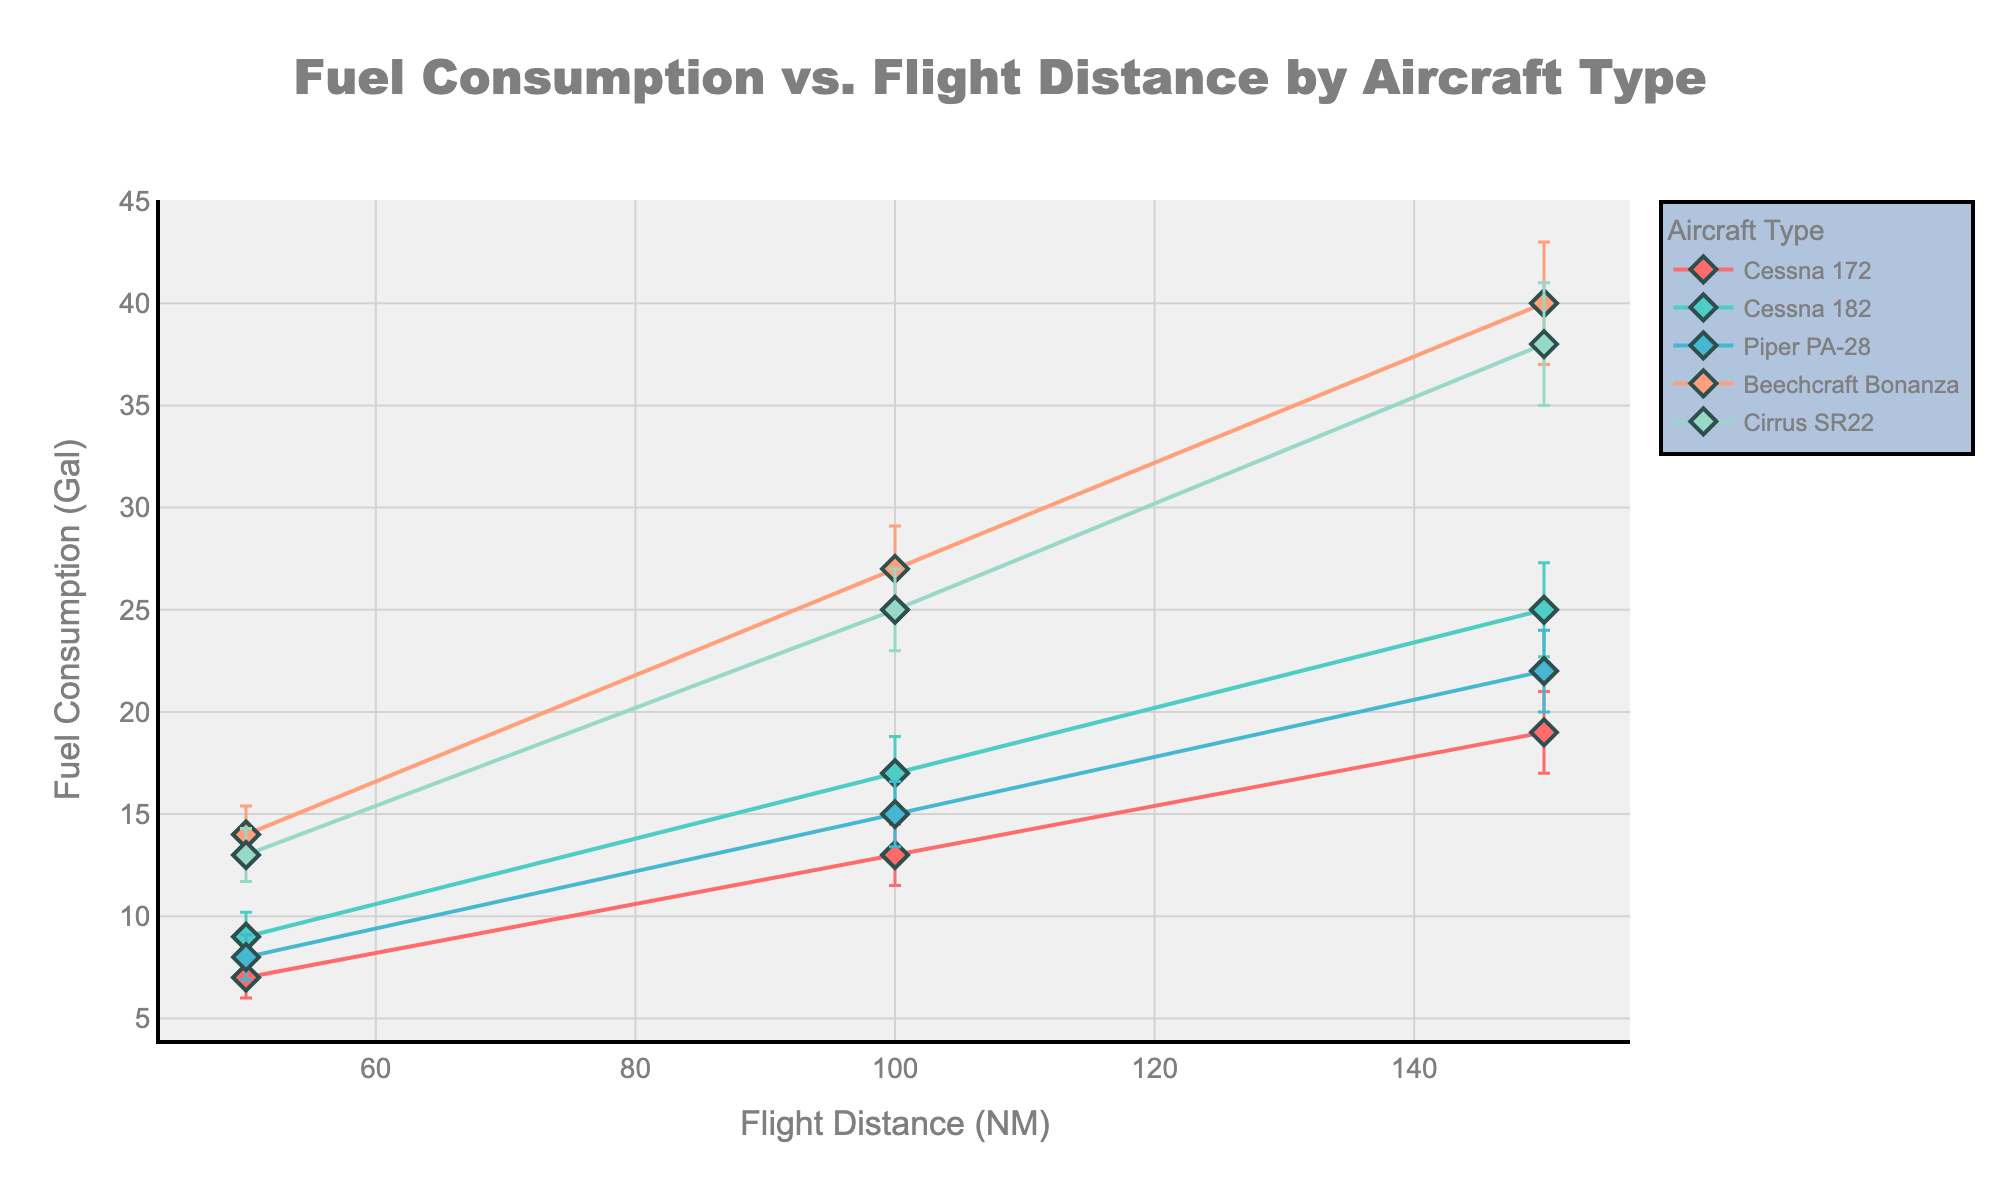How many data points are there for the Cessna 172 aircraft type? To find the number of data points for the Cessna 172, look at the distinct points where "Cessna 172" is plotted on the graph. There are three points, each corresponding to flight distances of 50, 100, and 150 NM.
Answer: 3 What is the range of fuel consumption for the Beechcraft Bonanza across the given flight distances? The range is the difference between the maximum and minimum values of fuel consumption for Beechcraft Bonanza. Maximum is 40 gallons (at 150 NM) and minimum is 14 gallons (at 50 NM), so the range is 40 - 14.
Answer: 26 gallons Which aircraft type has the highest fuel consumption for a 100 NM flight, and what is the value? To determine this, compare the fuel consumption at 100 NM for all aircraft types. The Beechcraft Bonanza consumes 27 gallons, which is higher than the other aircraft types.
Answer: Beechcraft Bonanza, 27 gallons What is the average fuel consumption at 100 NM across all aircraft types? First, sum the fuel consumption at 100 NM for all aircraft types: 13 (Cessna 172) + 17 (Cessna 182) + 15 (Piper PA-28) + 27 (Beechcraft Bonanza) + 25 (Cirrus SR22). The total is 97 gallons. Then, divide by the number of aircraft types (5).
Answer: 19.4 gallons Which aircraft type shows the greatest variability in fuel consumption for a 150 NM flight? The variability can be assessed by comparing the error bars (standard deviation) for each aircraft at 150 NM. Beechcraft Bonanza has the widest error bar, indicating the highest variability with a standard deviation of 3 gallons.
Answer: Beechcraft Bonanza How does the fuel consumption of the Cessna 182 compare to the Piper PA-28 at 50 NM? Compare the fuel consumption values directly. Cessna 182 consumes 9 gallons, while Piper PA-28 consumes 8 gallons.
Answer: Cessna 182 consumes more by 1 gallon Is there any aircraft type whose fuel consumption at 100 NM is exactly double that at 50 NM? By examining each aircraft type: 
- Cessna 172: 13 (at 100 NM) vs. 7 (at 50 NM) → not double 
- Cessna 182: 17 (at 100 NM) vs. 9 (at 50 NM) → not double 
- Piper PA-28: 15 (at 100 NM) vs. 8 (at 50 NM) → not double 
- Beechcraft Bonanza: 27 (at 100 NM) vs. 14 (at 50 NM) → 28 is not 27 
- Cirrus SR22: 25 (at 100 NM) vs. 13 (at 50 NM) → not double 
None of the aircraft types fit the criteria.
Answer: None What is the error bar range for the Cirrus SR22 at 150 NM? The error bar range is calculated by adding and subtracting the standard deviation from the fuel consumption at 150 NM. The fuel consumption is 38 gallons, with a standard deviation of 3 gallons. The range is therefore 38 ± 3, or 35 to 41 gallons.
Answer: 35 to 41 gallons 